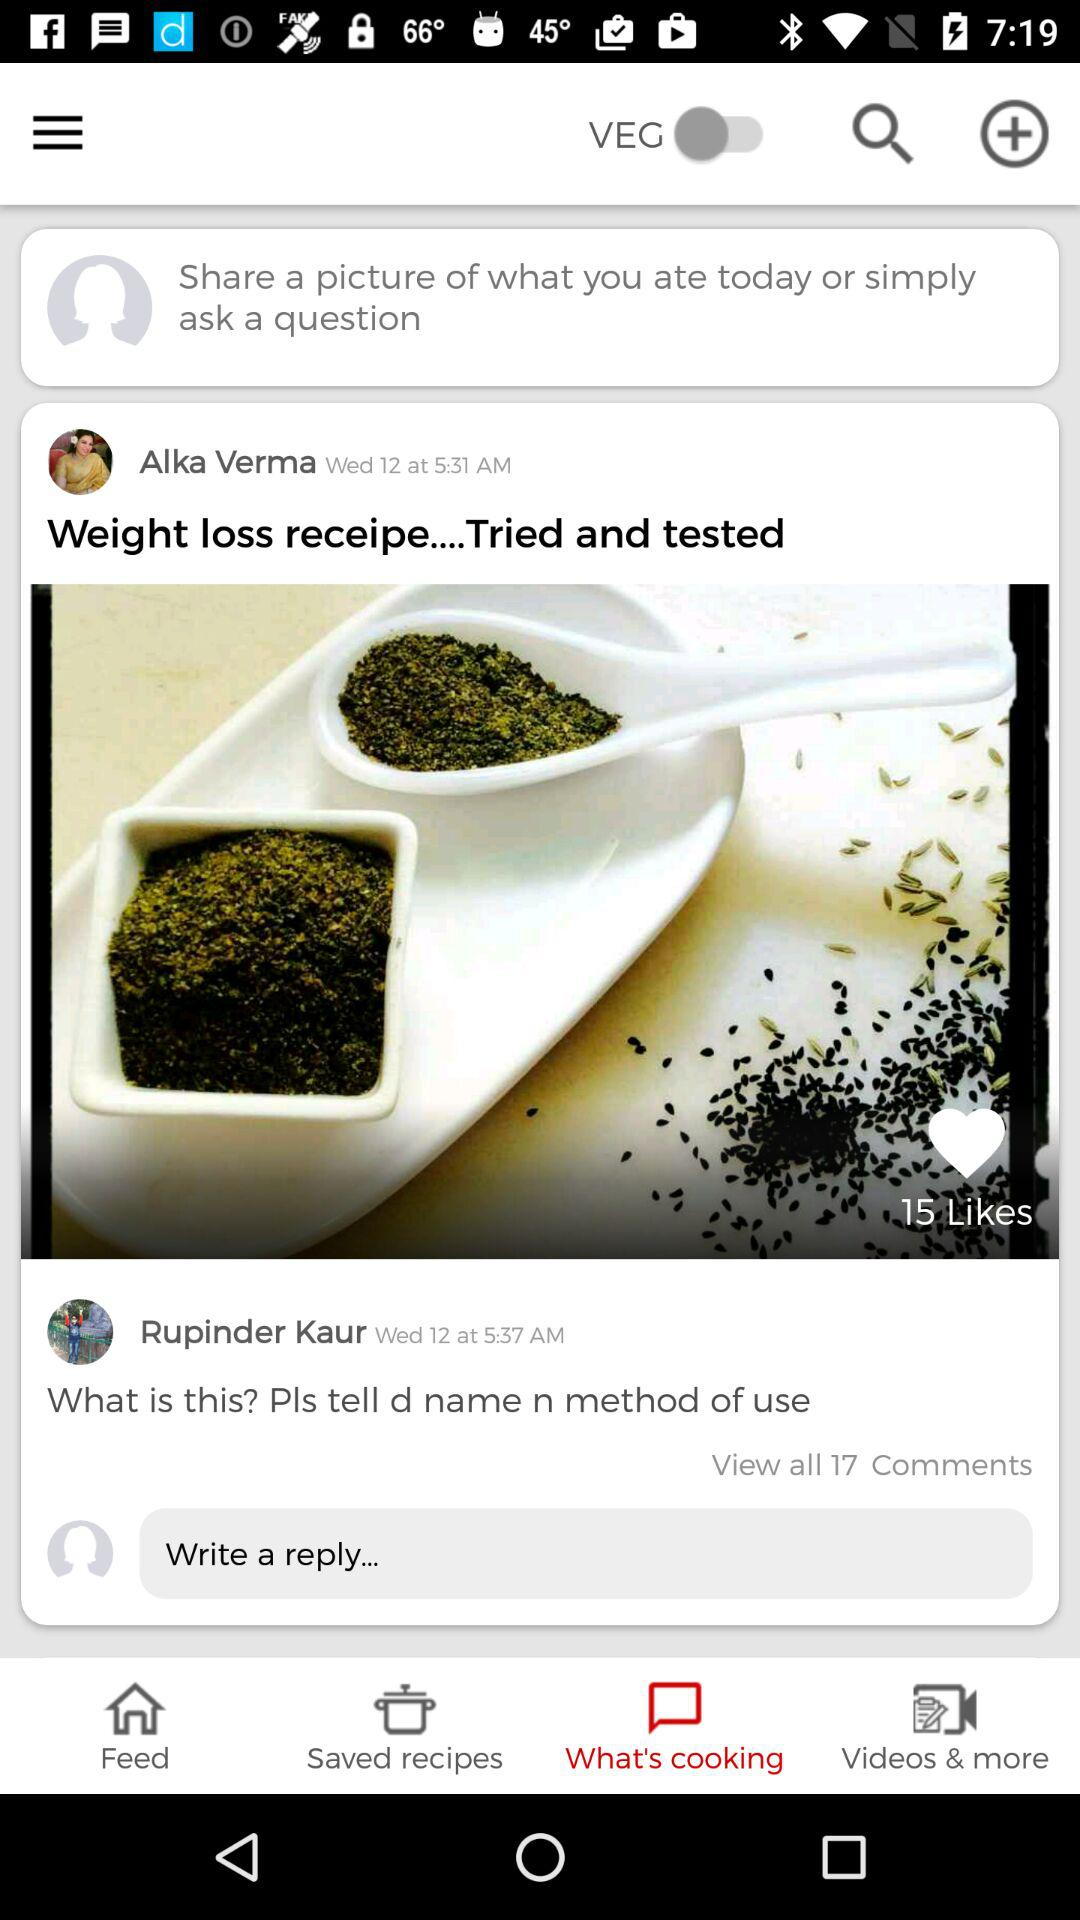When did Rupinder Kaur comment on the post? Rupinder Kaur commented on the post on Wednesday 12 at 5:37 AM. 